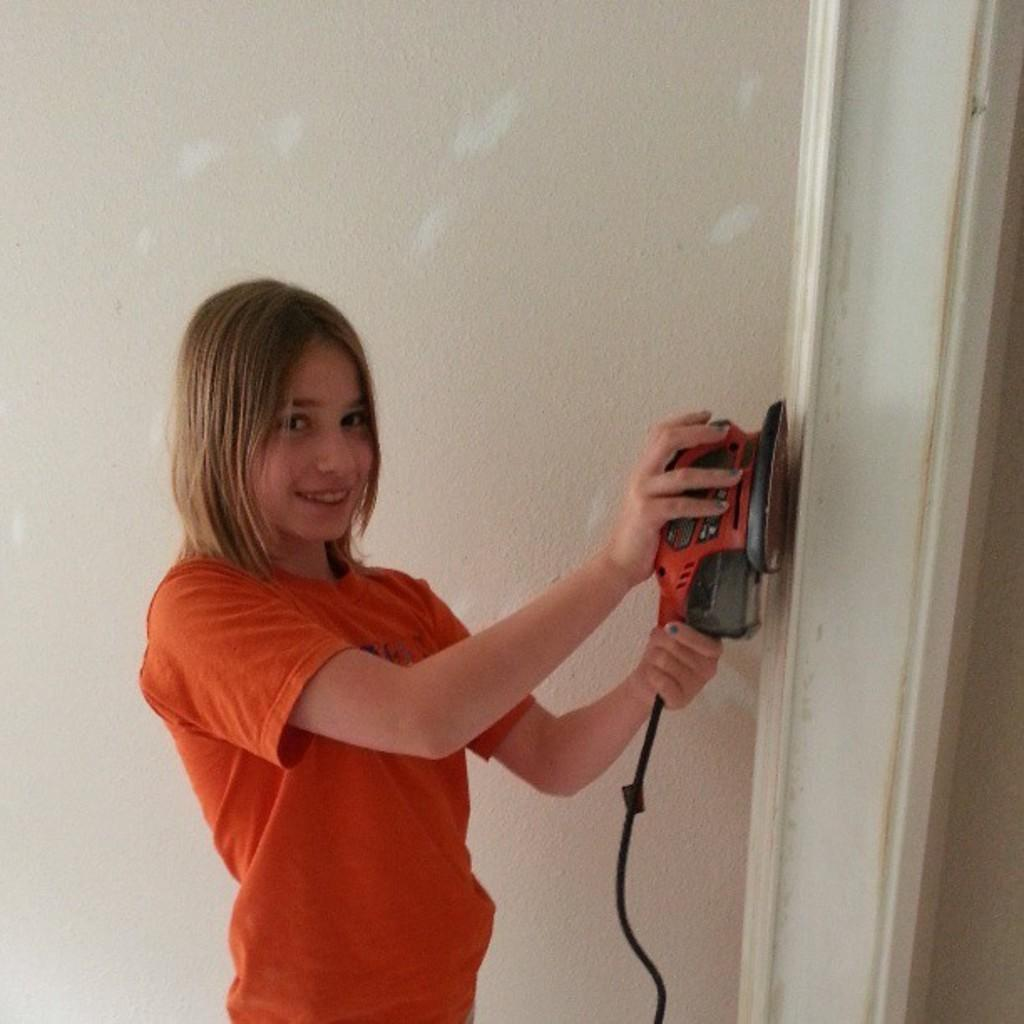Who is the main subject in the image? There is a girl in the image. What is the girl doing in the image? The girl is standing on the floor and holding a machine with a cable in her hands. What can be seen in the background of the image? There are walls in the background of the image. What type of lock is the girl using to secure the substance in the image? There is no lock or substance present in the image; it features a girl holding a machine with a cable. 